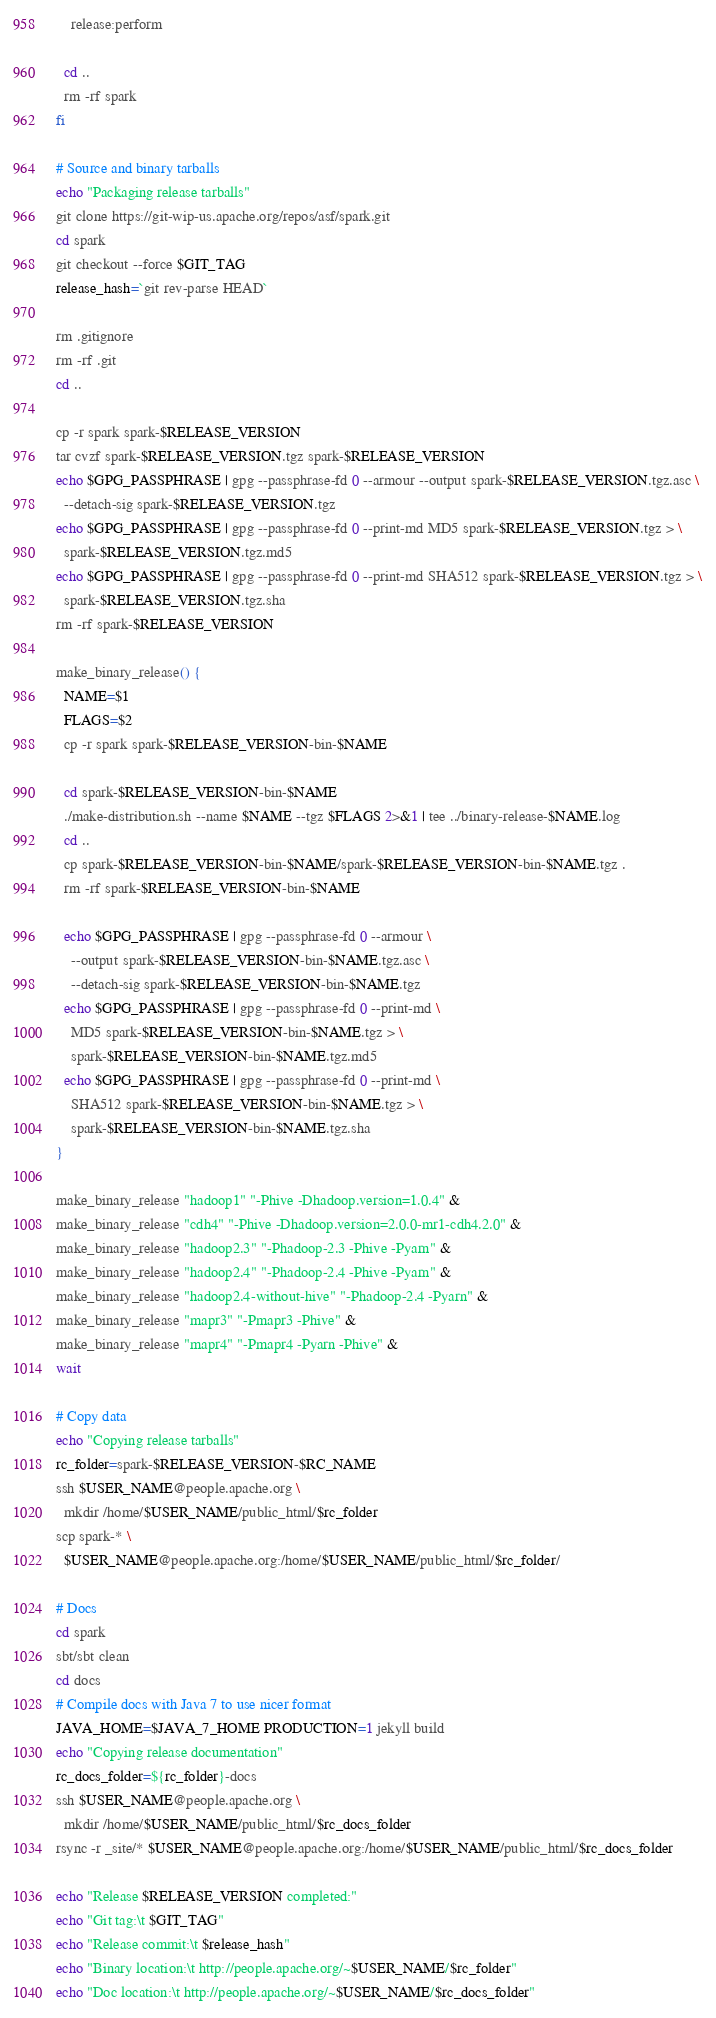<code> <loc_0><loc_0><loc_500><loc_500><_Bash_>    release:perform

  cd ..
  rm -rf spark
fi

# Source and binary tarballs
echo "Packaging release tarballs"
git clone https://git-wip-us.apache.org/repos/asf/spark.git
cd spark
git checkout --force $GIT_TAG
release_hash=`git rev-parse HEAD`

rm .gitignore
rm -rf .git
cd ..

cp -r spark spark-$RELEASE_VERSION
tar cvzf spark-$RELEASE_VERSION.tgz spark-$RELEASE_VERSION
echo $GPG_PASSPHRASE | gpg --passphrase-fd 0 --armour --output spark-$RELEASE_VERSION.tgz.asc \
  --detach-sig spark-$RELEASE_VERSION.tgz
echo $GPG_PASSPHRASE | gpg --passphrase-fd 0 --print-md MD5 spark-$RELEASE_VERSION.tgz > \
  spark-$RELEASE_VERSION.tgz.md5
echo $GPG_PASSPHRASE | gpg --passphrase-fd 0 --print-md SHA512 spark-$RELEASE_VERSION.tgz > \
  spark-$RELEASE_VERSION.tgz.sha
rm -rf spark-$RELEASE_VERSION

make_binary_release() {
  NAME=$1
  FLAGS=$2
  cp -r spark spark-$RELEASE_VERSION-bin-$NAME
  
  cd spark-$RELEASE_VERSION-bin-$NAME
  ./make-distribution.sh --name $NAME --tgz $FLAGS 2>&1 | tee ../binary-release-$NAME.log
  cd ..
  cp spark-$RELEASE_VERSION-bin-$NAME/spark-$RELEASE_VERSION-bin-$NAME.tgz .
  rm -rf spark-$RELEASE_VERSION-bin-$NAME

  echo $GPG_PASSPHRASE | gpg --passphrase-fd 0 --armour \
    --output spark-$RELEASE_VERSION-bin-$NAME.tgz.asc \
    --detach-sig spark-$RELEASE_VERSION-bin-$NAME.tgz
  echo $GPG_PASSPHRASE | gpg --passphrase-fd 0 --print-md \
    MD5 spark-$RELEASE_VERSION-bin-$NAME.tgz > \
    spark-$RELEASE_VERSION-bin-$NAME.tgz.md5
  echo $GPG_PASSPHRASE | gpg --passphrase-fd 0 --print-md \
    SHA512 spark-$RELEASE_VERSION-bin-$NAME.tgz > \
    spark-$RELEASE_VERSION-bin-$NAME.tgz.sha
}

make_binary_release "hadoop1" "-Phive -Dhadoop.version=1.0.4" &
make_binary_release "cdh4" "-Phive -Dhadoop.version=2.0.0-mr1-cdh4.2.0" &
make_binary_release "hadoop2.3" "-Phadoop-2.3 -Phive -Pyarn" &
make_binary_release "hadoop2.4" "-Phadoop-2.4 -Phive -Pyarn" &
make_binary_release "hadoop2.4-without-hive" "-Phadoop-2.4 -Pyarn" &
make_binary_release "mapr3" "-Pmapr3 -Phive" &
make_binary_release "mapr4" "-Pmapr4 -Pyarn -Phive" &
wait

# Copy data
echo "Copying release tarballs"
rc_folder=spark-$RELEASE_VERSION-$RC_NAME
ssh $USER_NAME@people.apache.org \
  mkdir /home/$USER_NAME/public_html/$rc_folder
scp spark-* \
  $USER_NAME@people.apache.org:/home/$USER_NAME/public_html/$rc_folder/

# Docs
cd spark
sbt/sbt clean
cd docs
# Compile docs with Java 7 to use nicer format
JAVA_HOME=$JAVA_7_HOME PRODUCTION=1 jekyll build
echo "Copying release documentation"
rc_docs_folder=${rc_folder}-docs
ssh $USER_NAME@people.apache.org \
  mkdir /home/$USER_NAME/public_html/$rc_docs_folder
rsync -r _site/* $USER_NAME@people.apache.org:/home/$USER_NAME/public_html/$rc_docs_folder

echo "Release $RELEASE_VERSION completed:"
echo "Git tag:\t $GIT_TAG"
echo "Release commit:\t $release_hash"
echo "Binary location:\t http://people.apache.org/~$USER_NAME/$rc_folder"
echo "Doc location:\t http://people.apache.org/~$USER_NAME/$rc_docs_folder"
</code> 